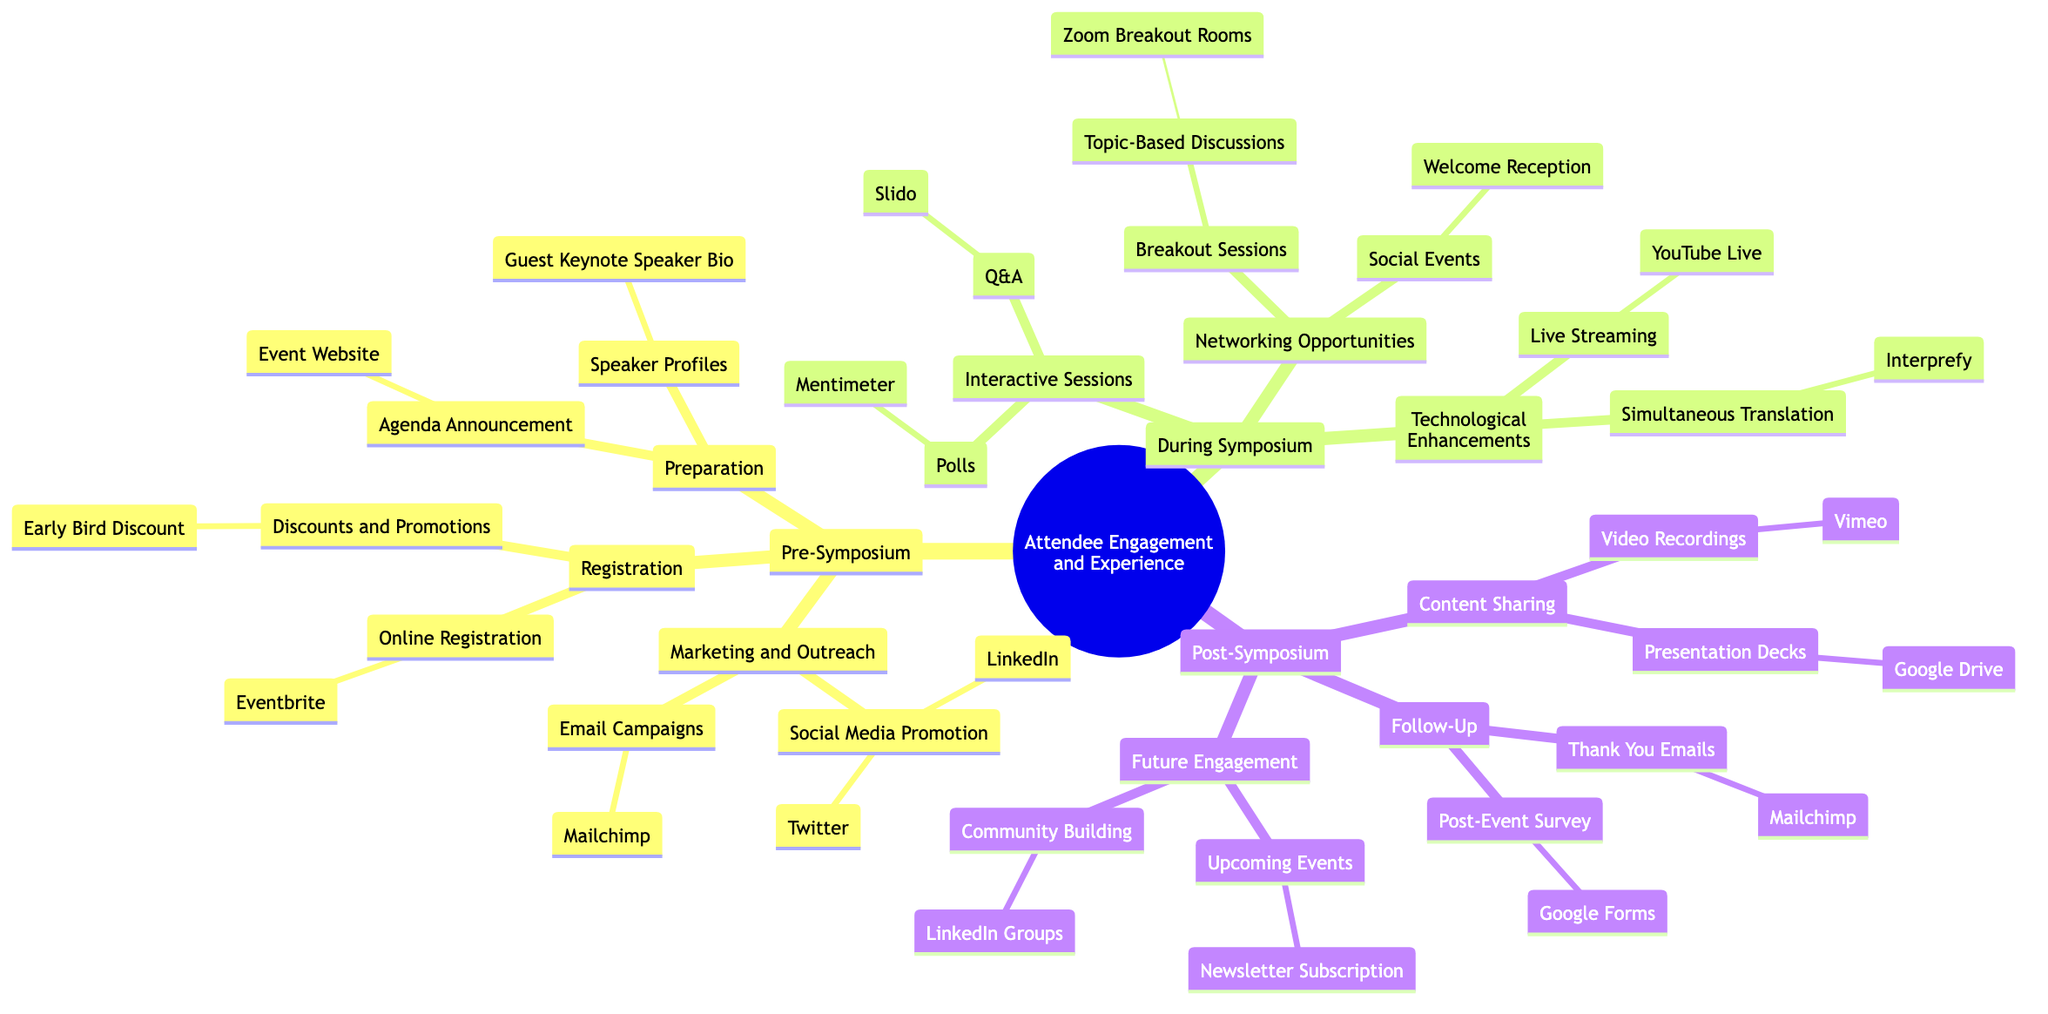What platform is used for email campaigns? The diagram lists "Mailchimp" under the "Email Campaigns" node in the "Marketing and Outreach" section of the "Pre-Symposium" category.
Answer: Mailchimp What is the early bird discount related to? The "Early Bird Discount" node is categorized under "Discounts and Promotions" in the "Registration" section during the "Pre-Symposium" phase, indicating it relates to registration fees.
Answer: Registration How many main sections are there in the mind map? The diagram shows three main sections: "Pre-Symposium," "During Symposium," and "Post-Symposium." By counting these sections, we can determine that there are three.
Answer: 3 What tool is used for post-event surveys? The "Post-Event Survey" node under "Follow-Up" in the "Post-Symposium" section indicates that "Google Forms" is the tool used for creating and distributing the survey.
Answer: Google Forms Which platform is used for live streaming? The diagram specifies "YouTube Live" under the "Live Streaming" node in the "Technological Enhancements" section of the "During Symposium" category.
Answer: YouTube Live How do attendees engage with interactive sessions? Attendees engage through Q&A using "Slido" and polls using "Mentimeter." This is represented under the "Interactive Sessions" node in the "During Symposium" section.
Answer: Slido, Mentimeter What type of discussions are held in breakout sessions? The "Topic-Based Discussions" node outlines that these discussions, categorized under "Breakout Sessions" in the "Networking Opportunities," focus on specific topics.
Answer: Specific topics What follow-up method is used to express gratitude after the symposium? The "Thank You Emails" node indicates that "Mailchimp" is utilized for sending follow-up gratitude emails in the "Follow-Up" category of the "Post-Symposium" section.
Answer: Mailchimp How can attendees participate in community building post-symposium? The "Community Building" node under "Future Engagement" in the "Post-Symposium" section reveals that attendees can join "LinkedIn Groups" for community engagement.
Answer: LinkedIn Groups 